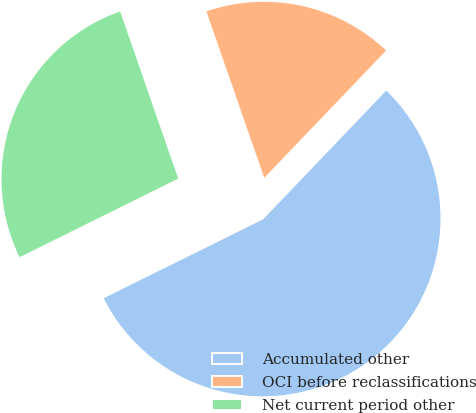<chart> <loc_0><loc_0><loc_500><loc_500><pie_chart><fcel>Accumulated other<fcel>OCI before reclassifications<fcel>Net current period other<nl><fcel>55.53%<fcel>17.47%<fcel>27.0%<nl></chart> 